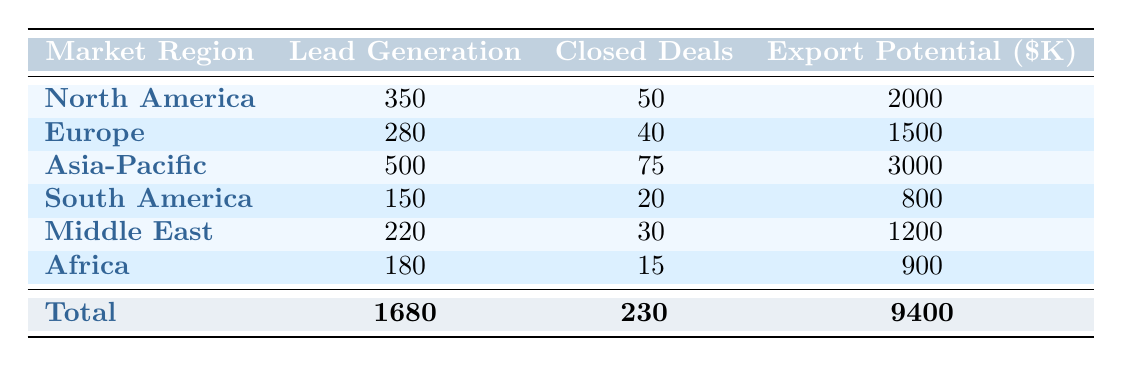What is the total lead generation across all market regions? To find the total lead generation, sum the "Lead Generation" figures from all market regions: 350 + 280 + 500 + 150 + 220 + 180 = 1680.
Answer: 1680 Which market region has the highest closed deals? By comparing the "Closed Deals" for each market region, Asia-Pacific has the highest value of 75.
Answer: Asia-Pacific What is the average export potential for the market regions listed? To find the average export potential, first, sum the export potentials: 2000000 + 1500000 + 3000000 + 800000 + 1200000 + 900000 = 9400000. Then, divide by the number of market regions (6): 9400000 / 6 = 1566667.
Answer: 1566667 Is the total number of closed deals greater than 200? The total number of closed deals calculated from the table is 230, which is greater than 200. Therefore, the answer is yes.
Answer: Yes What is the ratio of closed deals to lead generation for North America? For North America, closed deals are 50 and lead generation is 350. The ratio is calculated by dividing closed deals by lead generation: 50 / 350 = 0.142857, or approximately 0.14 when rounded.
Answer: 0.14 Which market region generated the least leads? Looking at the "Lead Generation" column, South America has the least amount with 150 leads.
Answer: South America What is the combined export potential of the Asia-Pacific and South America regions? To find the combined export potential, add the values for these two regions: 3000000 (Asia-Pacific) + 800000 (South America) = 3800000.
Answer: 3800000 Has Eco Plastics Inc. closed more deals than GreenTech Solutions? Eco Plastics Inc. closed 20 deals while GreenTech Solutions closed 15 deals, which indicates that Eco Plastics Inc. has closed more deals.
Answer: Yes What percentage of closed deals does the Middle East represent of the total closed deals? The Middle East has 30 closed deals out of a total of 230 closed deals. To calculate the percentage, divide 30 by 230 and multiply by 100: (30 / 230) * 100 = 13.04%.
Answer: 13.04% 